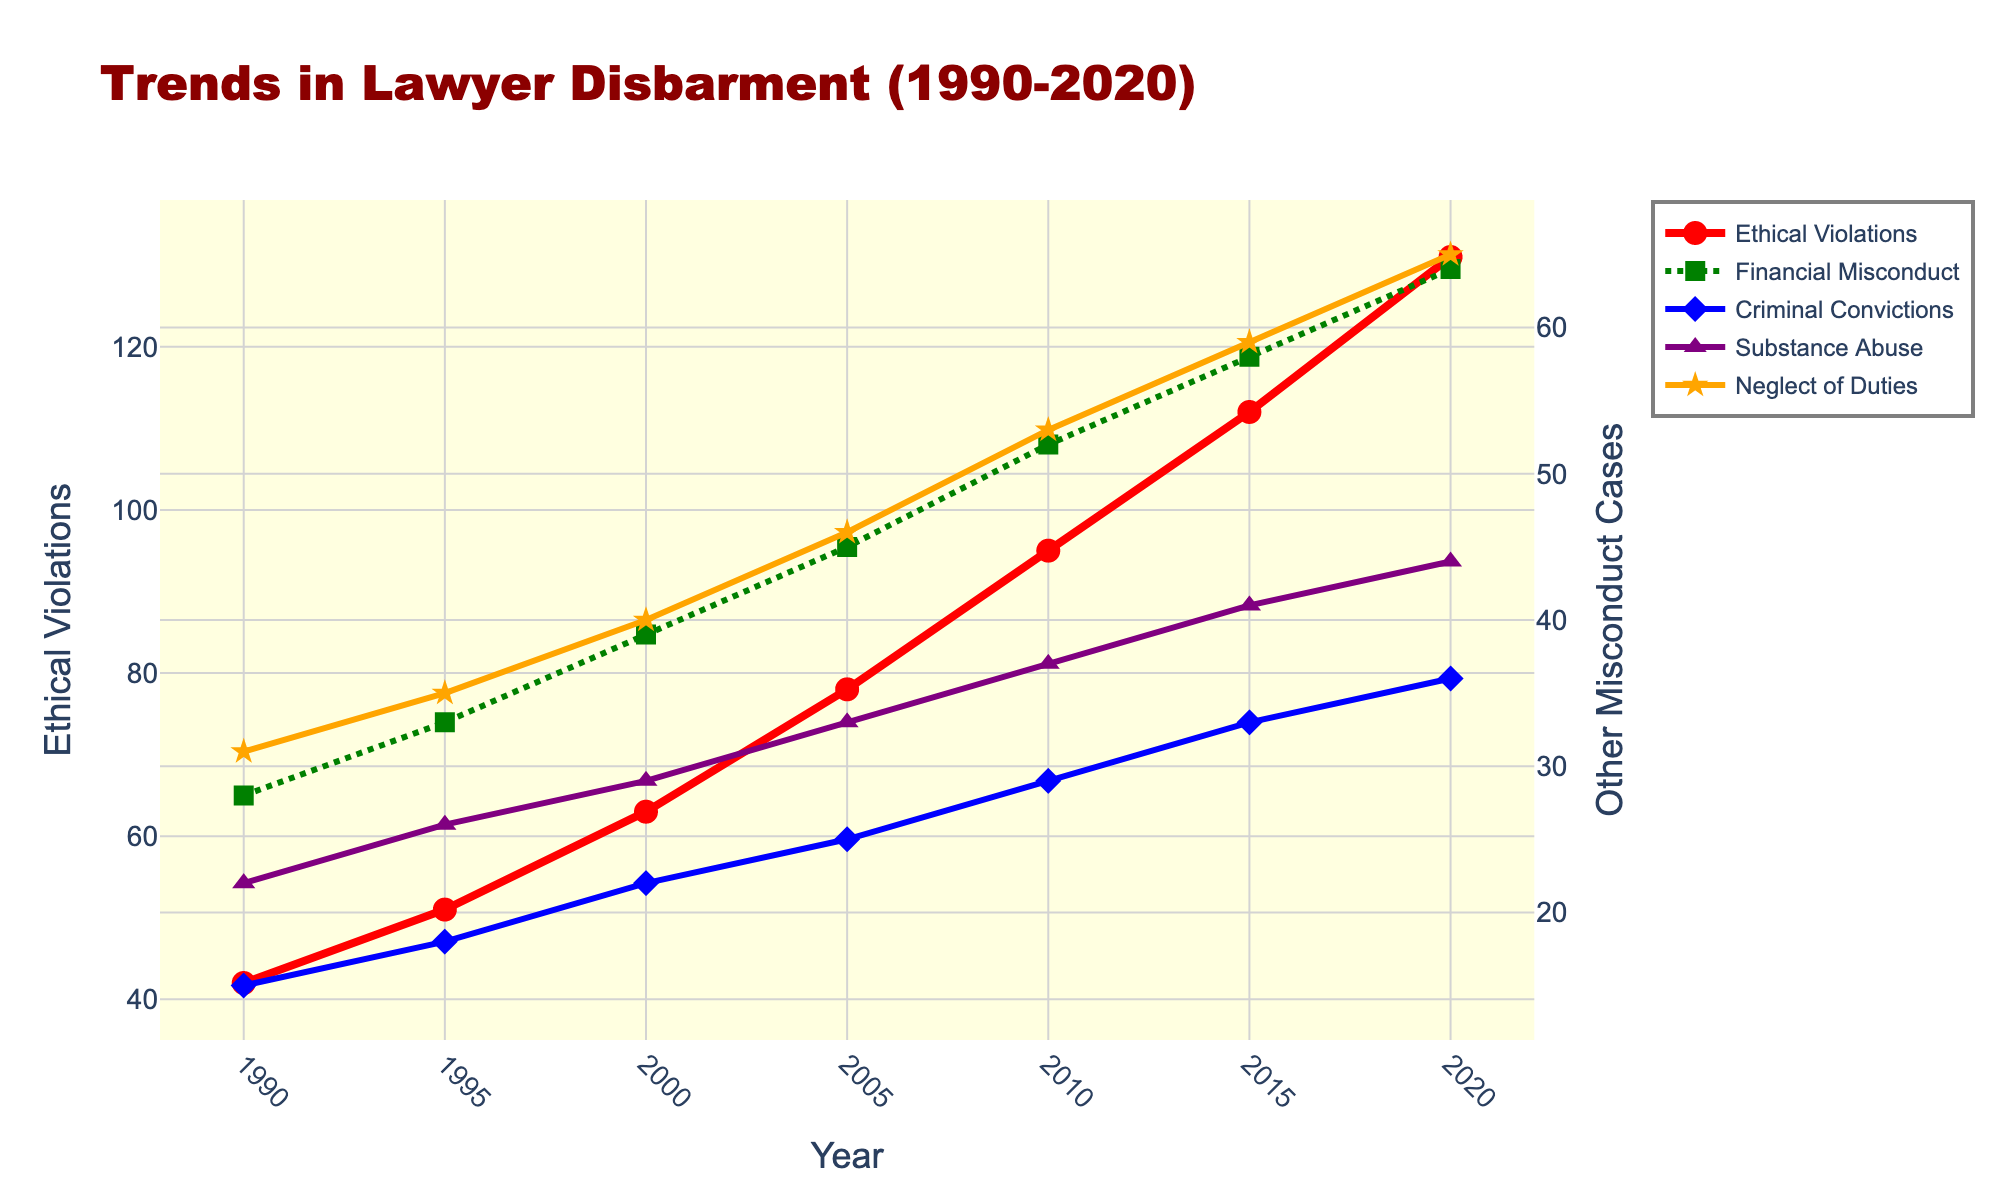what year does Ethical Violations surpass 100 cases? The red line represents Ethical Violations. It can be seen surpassing 100 cases around 2015.
Answer: 2015 Which misconduct category showed the least increase in disbarment cases from 1990 to 2020? Comparing the start and end points of each line, Criminal Convictions increased from 15 to 36, which is the smallest change among all categories.
Answer: Criminal Convictions How many more Ethical Violations were there in 2020 compared to Financial Misconduct? In 2020, Ethical Violations had 131 cases, and Financial Misconduct had 64. The difference is 131 - 64 = 67.
Answer: 67 In which time intervals did Ethical Violations see the highest rate of increase? To find where the line steepens most sharply, compare the intervals: 1990-95 (+9), 1995-2000 (+12), 2000-05 (+15), 2005-10 (+17), 2010-15 (+17), 2015-20 (+19). The largest increases are between 2005-10 and 2010-15.
Answer: 2010-2015 and 2015-2020 How do the final values of Substance Abuse and Neglect of Duties in 2020 compare? The purple line for Substance Abuse ends at 44 in 2020, while the orange line for Neglect of Duties ends at 65. So, there are 21 fewer cases in Substance Abuse.
Answer: Substance Abuse is 21 less than Neglect of Duties Which misconduct category had the highest value in the mid-point year of 2005? By examining the heights at 2005, Ethical Violations is the highest at 78 cases.
Answer: Ethical Violations Calculate the average number of cases for Financial Misconduct over the 30-year period. Sum all Financial Misconduct cases: 28 + 33 + 39 + 45 + 52 + 58 + 64 = 319. There are 7 data points, so 319 / 7 gives approximately 45.57.
Answer: 45.57 Is the trend of Ethical Violations consistent compared to other misconduct categories? The red line for Ethical Violations has a steeper and more consistent upward trend, while other lines show gentler slopes or plateaus, indicating less consistent trends.
Answer: Yes Between 1995 and 2000, which misconduct category saw the smallest increase in disbarment cases? Calculate the differences between values in 1995 and 2000 for each category. Criminal Convictions increased from 18 to 22, only a 4 case increase, which is the smallest.
Answer: Criminal Convictions 